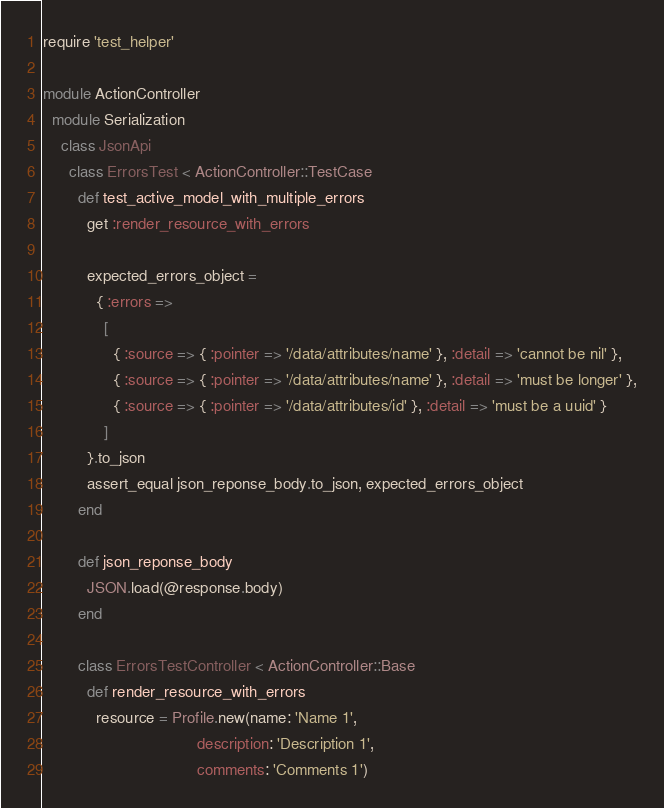Convert code to text. <code><loc_0><loc_0><loc_500><loc_500><_Ruby_>require 'test_helper'

module ActionController
  module Serialization
    class JsonApi
      class ErrorsTest < ActionController::TestCase
        def test_active_model_with_multiple_errors
          get :render_resource_with_errors

          expected_errors_object =
            { :errors =>
              [
                { :source => { :pointer => '/data/attributes/name' }, :detail => 'cannot be nil' },
                { :source => { :pointer => '/data/attributes/name' }, :detail => 'must be longer' },
                { :source => { :pointer => '/data/attributes/id' }, :detail => 'must be a uuid' }
              ]
          }.to_json
          assert_equal json_reponse_body.to_json, expected_errors_object
        end

        def json_reponse_body
          JSON.load(@response.body)
        end

        class ErrorsTestController < ActionController::Base
          def render_resource_with_errors
            resource = Profile.new(name: 'Name 1',
                                   description: 'Description 1',
                                   comments: 'Comments 1')</code> 